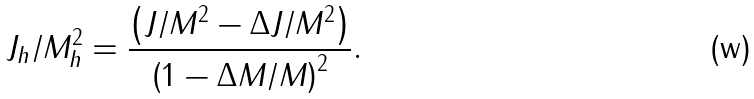<formula> <loc_0><loc_0><loc_500><loc_500>J _ { h } / M _ { h } ^ { 2 } = \frac { \left ( J / M ^ { 2 } - \Delta J / M ^ { 2 } \right ) } { \left ( 1 - \Delta M / M \right ) ^ { 2 } } .</formula> 